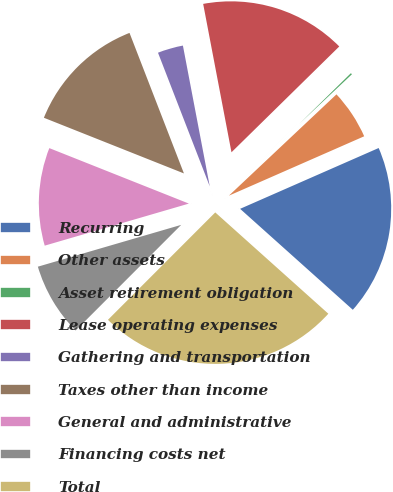<chart> <loc_0><loc_0><loc_500><loc_500><pie_chart><fcel>Recurring<fcel>Other assets<fcel>Asset retirement obligation<fcel>Lease operating expenses<fcel>Gathering and transportation<fcel>Taxes other than income<fcel>General and administrative<fcel>Financing costs net<fcel>Total<nl><fcel>18.21%<fcel>5.44%<fcel>0.33%<fcel>15.65%<fcel>2.88%<fcel>13.1%<fcel>10.54%<fcel>7.99%<fcel>25.87%<nl></chart> 